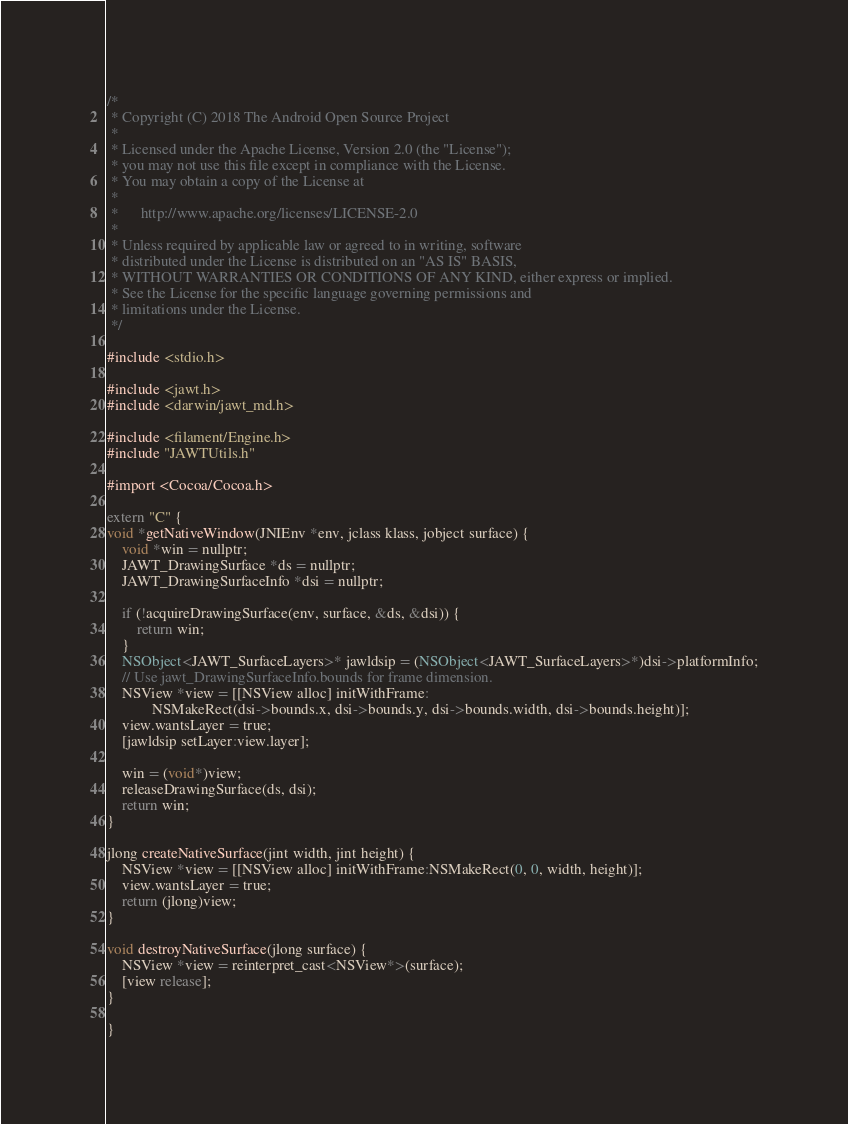Convert code to text. <code><loc_0><loc_0><loc_500><loc_500><_ObjectiveC_>/*
 * Copyright (C) 2018 The Android Open Source Project
 *
 * Licensed under the Apache License, Version 2.0 (the "License");
 * you may not use this file except in compliance with the License.
 * You may obtain a copy of the License at
 *
 *      http://www.apache.org/licenses/LICENSE-2.0
 *
 * Unless required by applicable law or agreed to in writing, software
 * distributed under the License is distributed on an "AS IS" BASIS,
 * WITHOUT WARRANTIES OR CONDITIONS OF ANY KIND, either express or implied.
 * See the License for the specific language governing permissions and
 * limitations under the License.
 */

#include <stdio.h>

#include <jawt.h>
#include <darwin/jawt_md.h>

#include <filament/Engine.h>
#include "JAWTUtils.h"

#import <Cocoa/Cocoa.h>

extern "C" {
void *getNativeWindow(JNIEnv *env, jclass klass, jobject surface) {
    void *win = nullptr;
    JAWT_DrawingSurface *ds = nullptr;
    JAWT_DrawingSurfaceInfo *dsi = nullptr;

    if (!acquireDrawingSurface(env, surface, &ds, &dsi)) {
        return win;
    }
    NSObject<JAWT_SurfaceLayers>* jawldsip = (NSObject<JAWT_SurfaceLayers>*)dsi->platformInfo;
    // Use jawt_DrawingSurfaceInfo.bounds for frame dimension.
    NSView *view = [[NSView alloc] initWithFrame:
            NSMakeRect(dsi->bounds.x, dsi->bounds.y, dsi->bounds.width, dsi->bounds.height)];
    view.wantsLayer = true;
    [jawldsip setLayer:view.layer];

    win = (void*)view;
    releaseDrawingSurface(ds, dsi);
    return win;
}

jlong createNativeSurface(jint width, jint height) {
    NSView *view = [[NSView alloc] initWithFrame:NSMakeRect(0, 0, width, height)];
    view.wantsLayer = true;
    return (jlong)view;
}

void destroyNativeSurface(jlong surface) {
    NSView *view = reinterpret_cast<NSView*>(surface);
    [view release];
}

}
</code> 